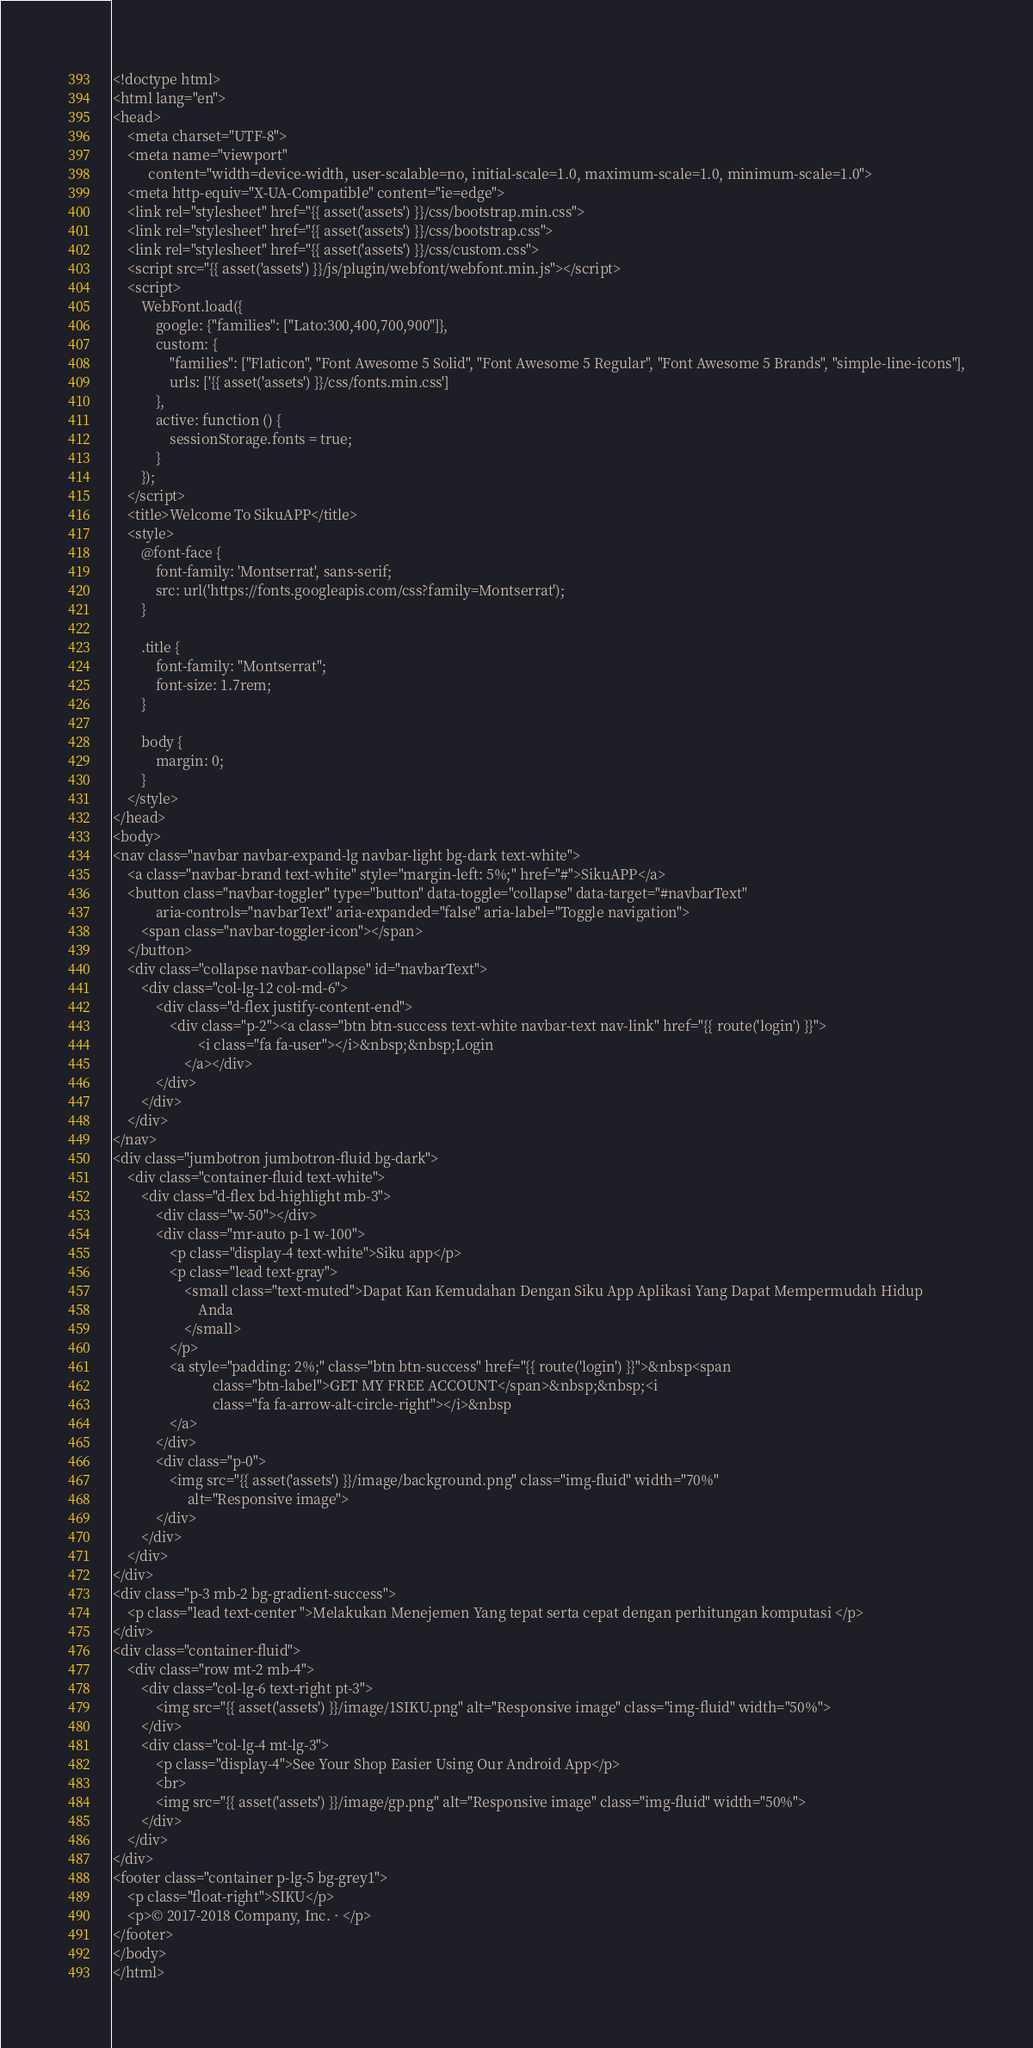<code> <loc_0><loc_0><loc_500><loc_500><_PHP_><!doctype html>
<html lang="en">
<head>
    <meta charset="UTF-8">
    <meta name="viewport"
          content="width=device-width, user-scalable=no, initial-scale=1.0, maximum-scale=1.0, minimum-scale=1.0">
    <meta http-equiv="X-UA-Compatible" content="ie=edge">
    <link rel="stylesheet" href="{{ asset('assets') }}/css/bootstrap.min.css">
    <link rel="stylesheet" href="{{ asset('assets') }}/css/bootstrap.css">
    <link rel="stylesheet" href="{{ asset('assets') }}/css/custom.css">
    <script src="{{ asset('assets') }}/js/plugin/webfont/webfont.min.js"></script>
    <script>
        WebFont.load({
            google: {"families": ["Lato:300,400,700,900"]},
            custom: {
                "families": ["Flaticon", "Font Awesome 5 Solid", "Font Awesome 5 Regular", "Font Awesome 5 Brands", "simple-line-icons"],
                urls: ['{{ asset('assets') }}/css/fonts.min.css']
            },
            active: function () {
                sessionStorage.fonts = true;
            }
        });
    </script>
    <title>Welcome To SikuAPP</title>
    <style>
        @font-face {
            font-family: 'Montserrat', sans-serif;
            src: url('https://fonts.googleapis.com/css?family=Montserrat');
        }

        .title {
            font-family: "Montserrat";
            font-size: 1.7rem;
        }

        body {
            margin: 0;
        }
    </style>
</head>
<body>
<nav class="navbar navbar-expand-lg navbar-light bg-dark text-white">
    <a class="navbar-brand text-white" style="margin-left: 5%;" href="#">SikuAPP</a>
    <button class="navbar-toggler" type="button" data-toggle="collapse" data-target="#navbarText"
            aria-controls="navbarText" aria-expanded="false" aria-label="Toggle navigation">
        <span class="navbar-toggler-icon"></span>
    </button>
    <div class="collapse navbar-collapse" id="navbarText">
        <div class="col-lg-12 col-md-6">
            <div class="d-flex justify-content-end">
                <div class="p-2"><a class="btn btn-success text-white navbar-text nav-link" href="{{ route('login') }}">
                        <i class="fa fa-user"></i>&nbsp;&nbsp;Login
                    </a></div>
            </div>
        </div>
    </div>
</nav>
<div class="jumbotron jumbotron-fluid bg-dark">
    <div class="container-fluid text-white">
        <div class="d-flex bd-highlight mb-3">
            <div class="w-50"></div>
            <div class="mr-auto p-1 w-100">
                <p class="display-4 text-white">Siku app</p>
                <p class="lead text-gray">
                    <small class="text-muted">Dapat Kan Kemudahan Dengan Siku App Aplikasi Yang Dapat Mempermudah Hidup
                        Anda
                    </small>
                </p>
                <a style="padding: 2%;" class="btn btn-success" href="{{ route('login') }}">&nbsp<span
                            class="btn-label">GET MY FREE ACCOUNT</span>&nbsp;&nbsp;<i
                            class="fa fa-arrow-alt-circle-right"></i>&nbsp
                </a>
            </div>
            <div class="p-0">
                <img src="{{ asset('assets') }}/image/background.png" class="img-fluid" width="70%"
                     alt="Responsive image">
            </div>
        </div>
    </div>
</div>
<div class="p-3 mb-2 bg-gradient-success">
    <p class="lead text-center ">Melakukan Menejemen Yang tepat serta cepat dengan perhitungan komputasi </p>
</div>
<div class="container-fluid">
    <div class="row mt-2 mb-4">
        <div class="col-lg-6 text-right pt-3">
            <img src="{{ asset('assets') }}/image/1SIKU.png" alt="Responsive image" class="img-fluid" width="50%">
        </div>
        <div class="col-lg-4 mt-lg-3">
            <p class="display-4">See Your Shop Easier Using Our Android App</p>
            <br>
            <img src="{{ asset('assets') }}/image/gp.png" alt="Responsive image" class="img-fluid" width="50%">
        </div>
    </div>
</div>
<footer class="container p-lg-5 bg-grey1">
    <p class="float-right">SIKU</p>
    <p>© 2017-2018 Company, Inc. · </p>
</footer>
</body>
</html></code> 